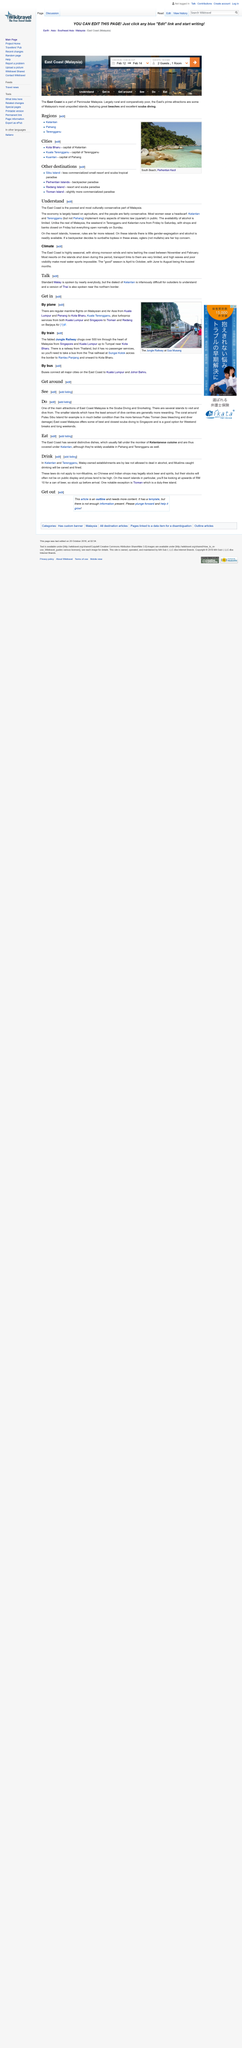Specify some key components in this picture. In Kelantan and Terengganu, Muslims who are caught dealing in alcohol will be canned and fined, and non-Muslims are not subject to these laws. The Monsoon season at the East Coast typically takes place between November and February, during which time heavy rainfall is common in the region. The Jungle Railway, which covers a distance of over 500km, chugs along, transporting passengers through the dense jungle. The East Coast is known for featuring a variety of unique and delicious dishes that set it apart from the rest of the coasts. Scuba diving and snorkeling are one of the main attractions of East Coast Malaysia, according to "Do". 